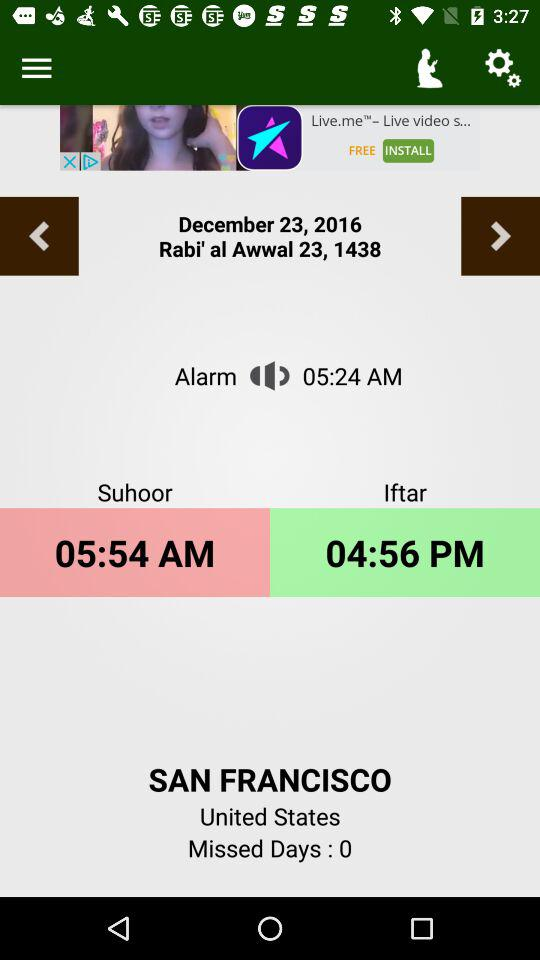What is the time of Iftar? The time of Iftar is 04:56 PM. 